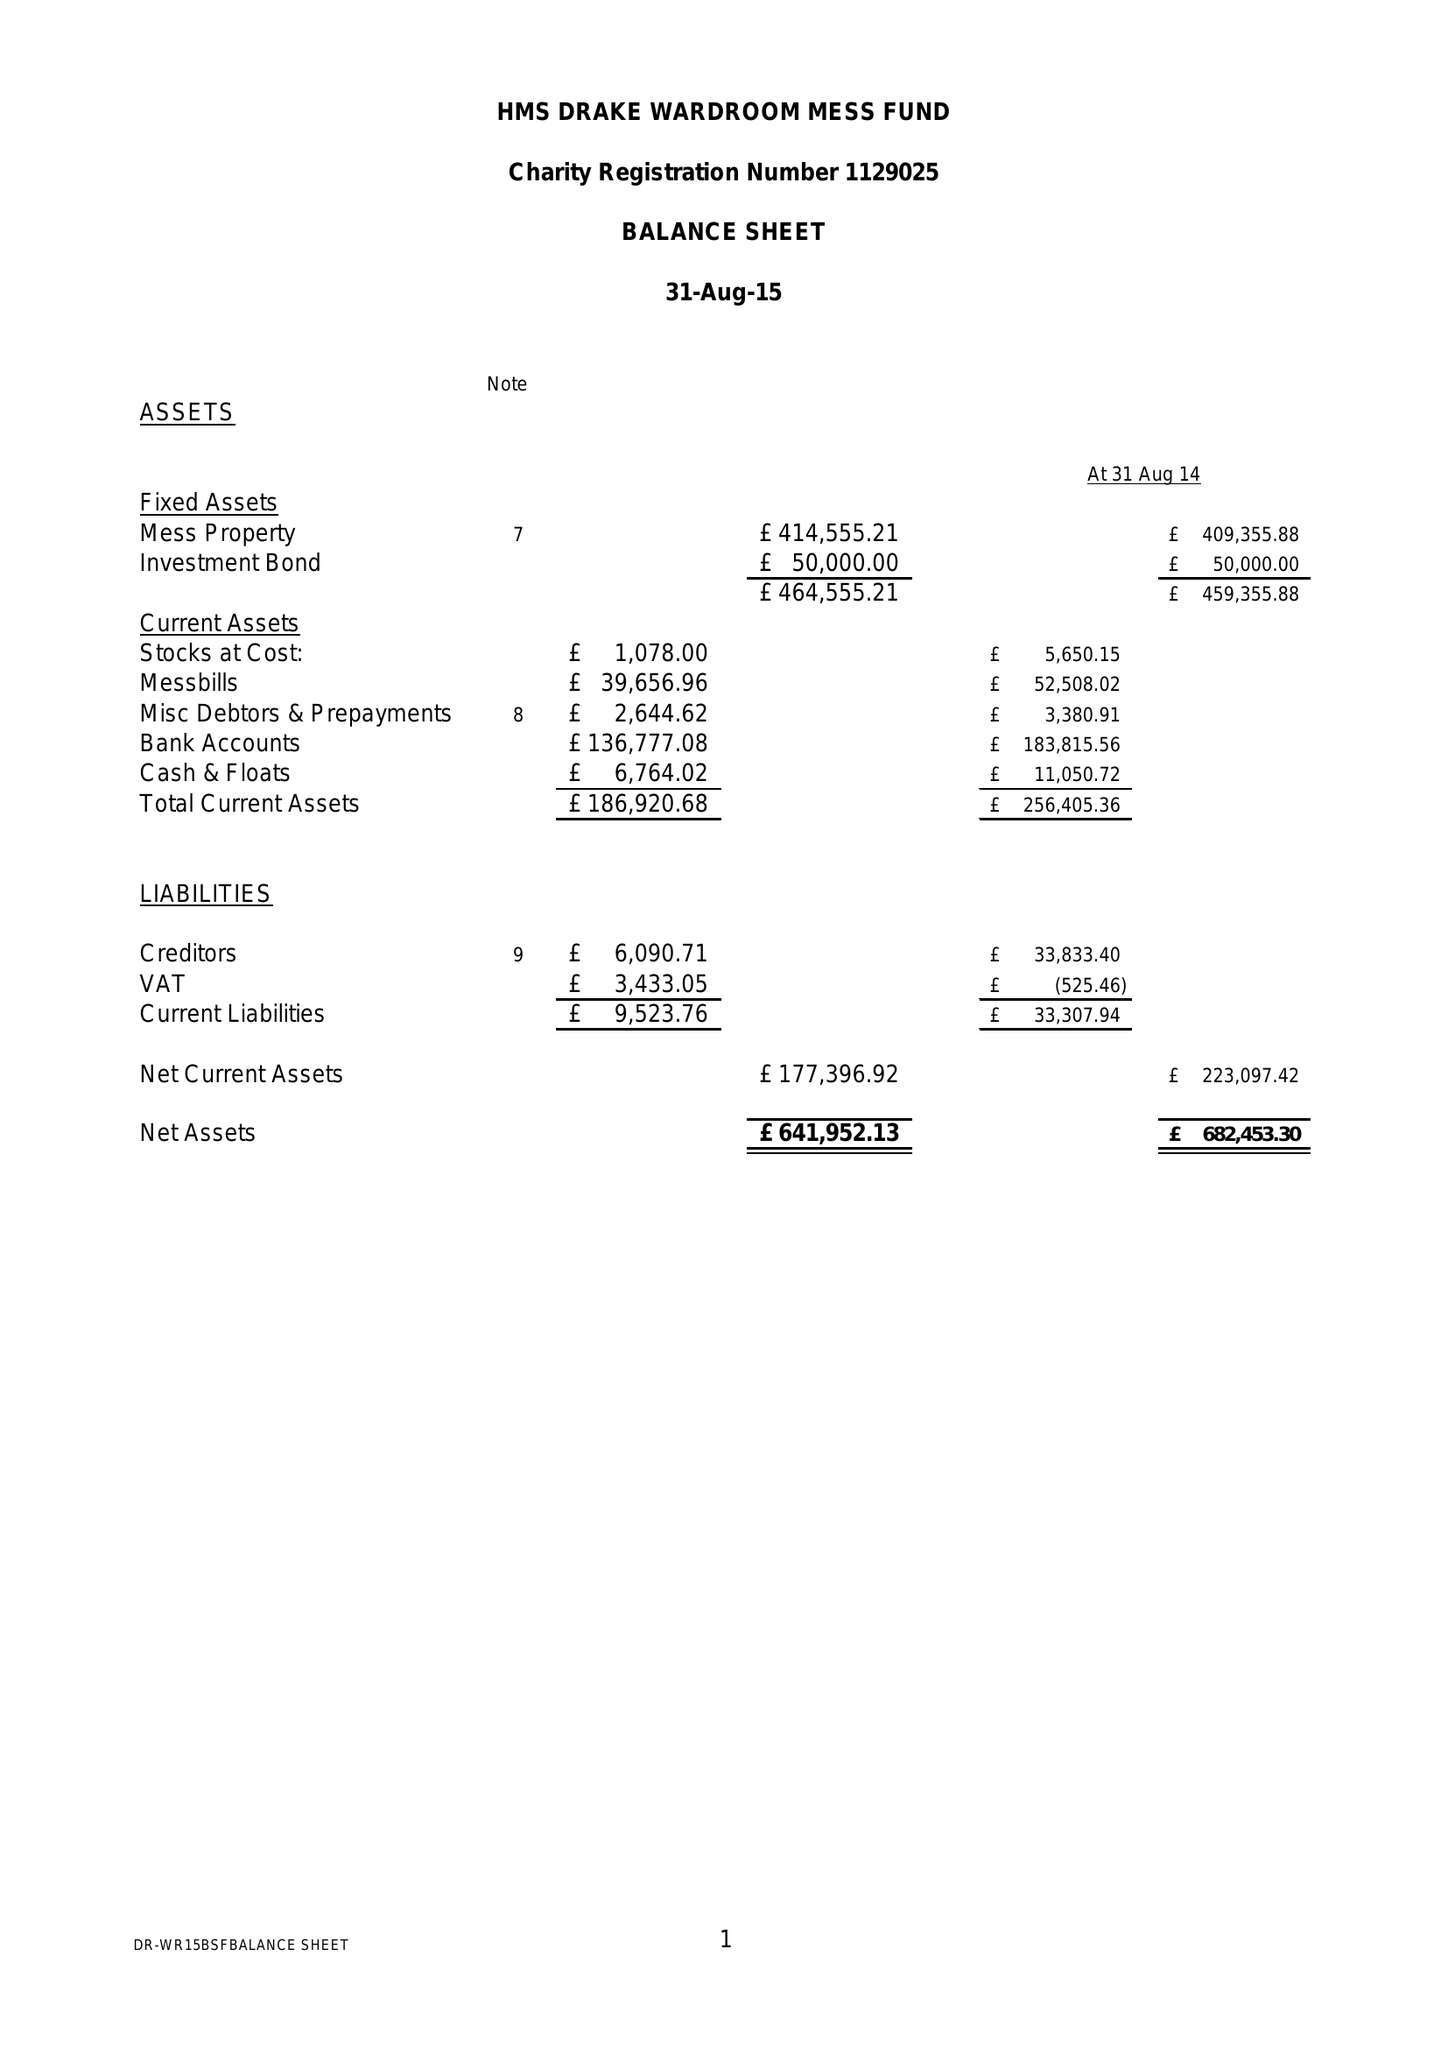What is the value for the charity_number?
Answer the question using a single word or phrase. 1129025 